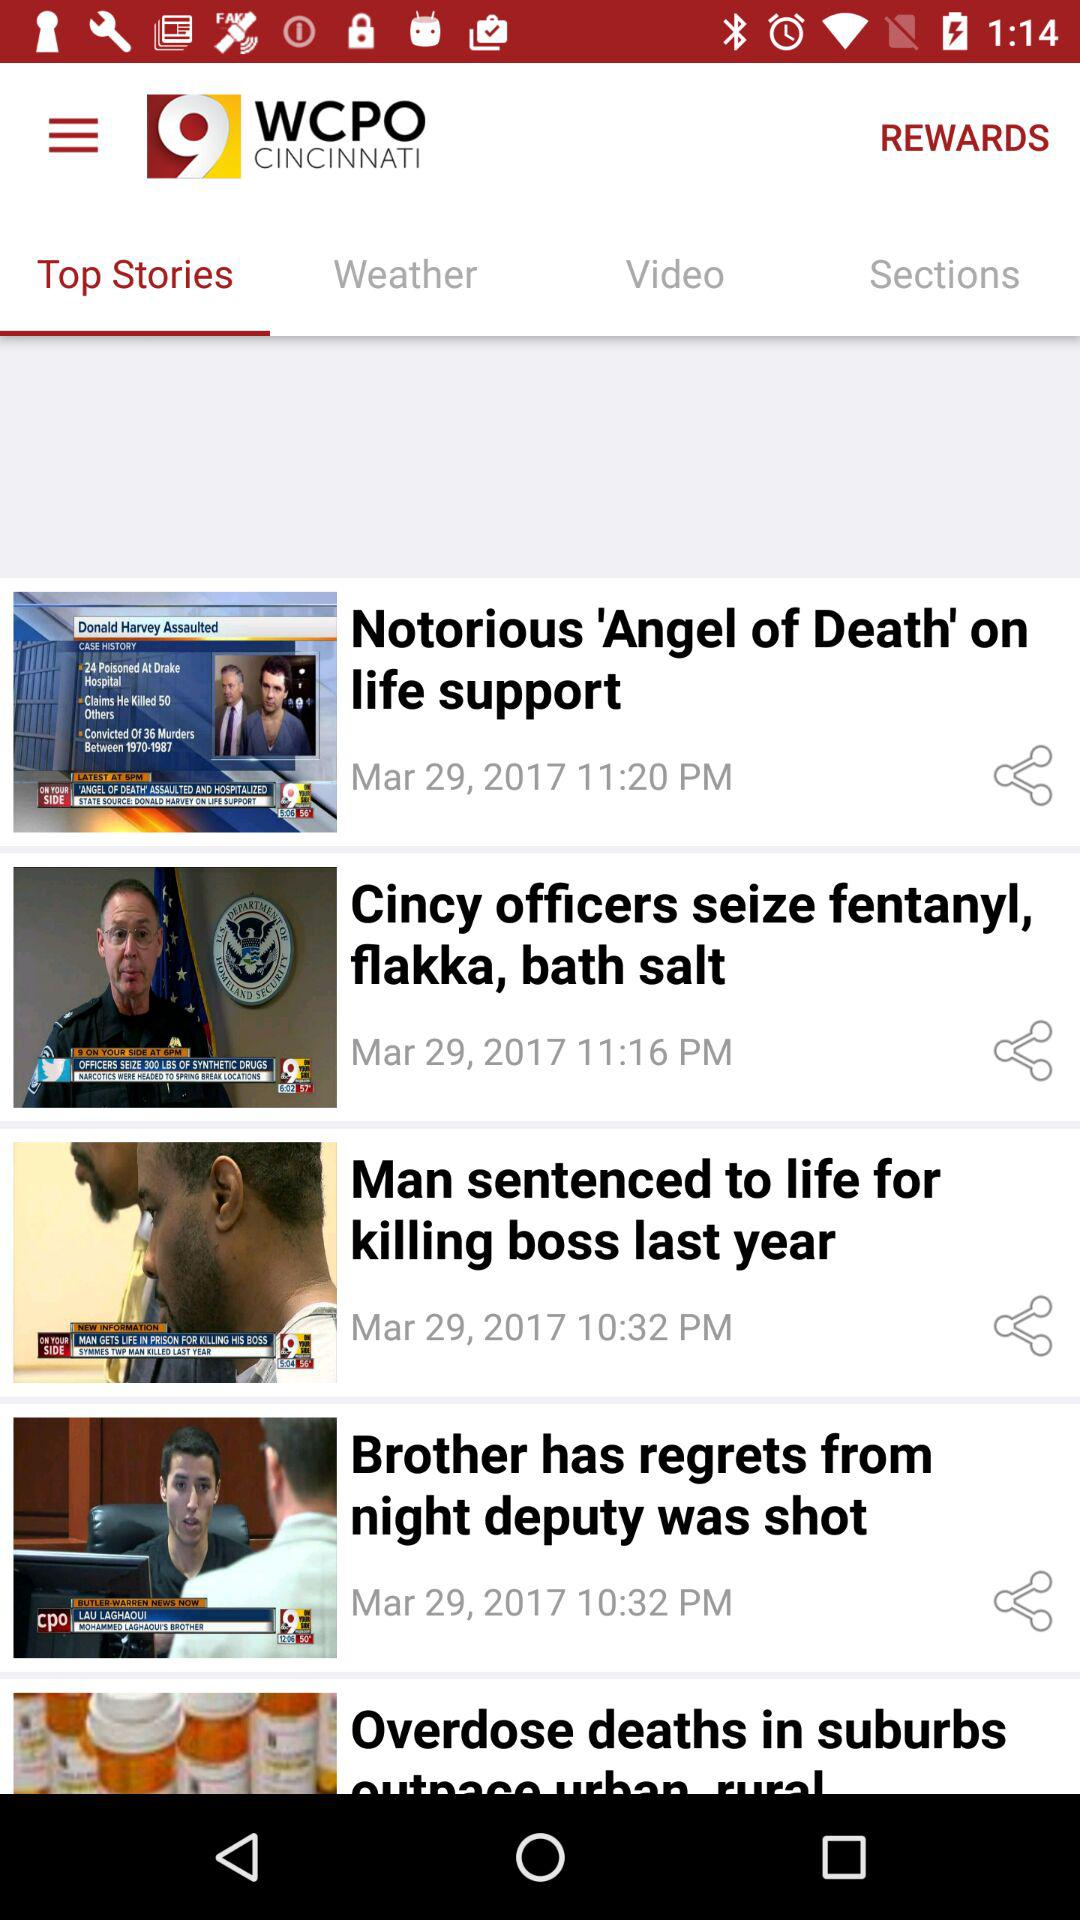How many news items are there?
Answer the question using a single word or phrase. 5 